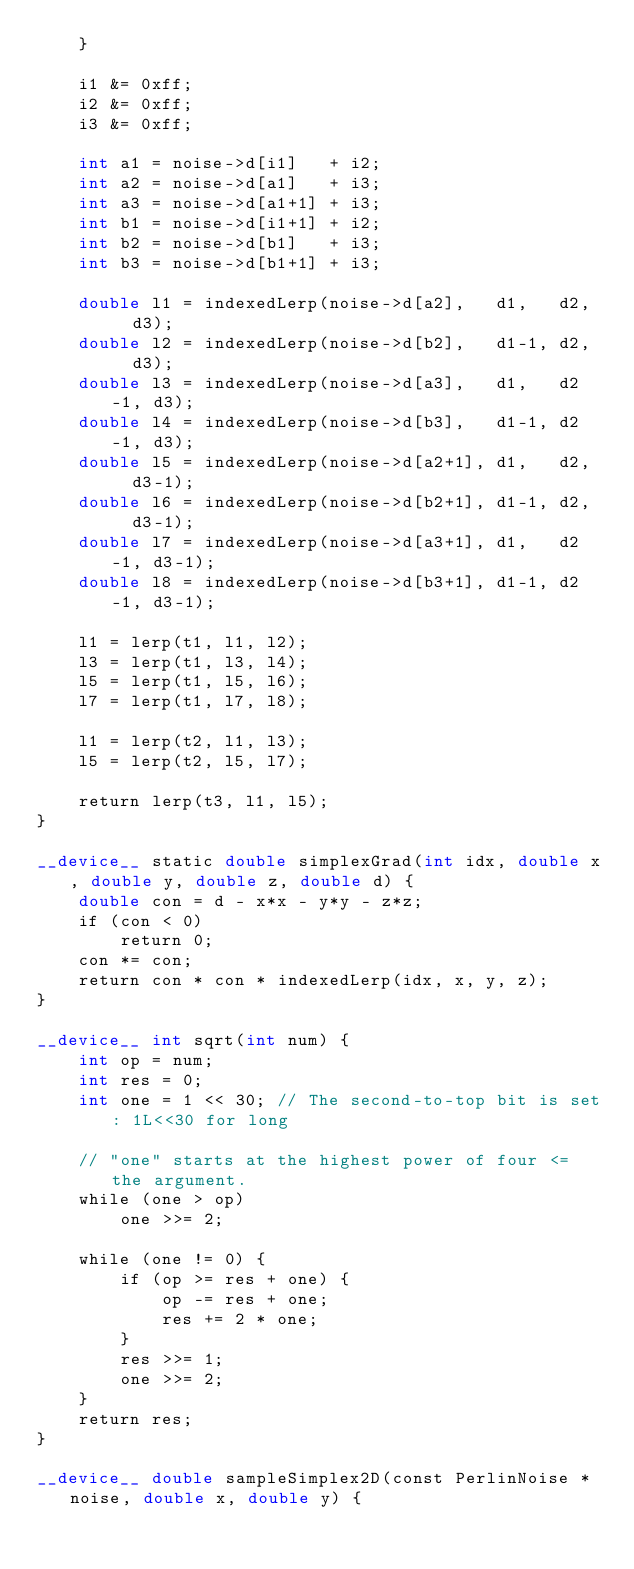<code> <loc_0><loc_0><loc_500><loc_500><_Cuda_>    }

    i1 &= 0xff;
    i2 &= 0xff;
    i3 &= 0xff;

    int a1 = noise->d[i1]   + i2;
    int a2 = noise->d[a1]   + i3;
    int a3 = noise->d[a1+1] + i3;
    int b1 = noise->d[i1+1] + i2;
    int b2 = noise->d[b1]   + i3;
    int b3 = noise->d[b1+1] + i3;

    double l1 = indexedLerp(noise->d[a2],   d1,   d2,   d3);
    double l2 = indexedLerp(noise->d[b2],   d1-1, d2,   d3);
    double l3 = indexedLerp(noise->d[a3],   d1,   d2-1, d3);
    double l4 = indexedLerp(noise->d[b3],   d1-1, d2-1, d3);
    double l5 = indexedLerp(noise->d[a2+1], d1,   d2,   d3-1);
    double l6 = indexedLerp(noise->d[b2+1], d1-1, d2,   d3-1);
    double l7 = indexedLerp(noise->d[a3+1], d1,   d2-1, d3-1);
    double l8 = indexedLerp(noise->d[b3+1], d1-1, d2-1, d3-1);

    l1 = lerp(t1, l1, l2);
    l3 = lerp(t1, l3, l4);
    l5 = lerp(t1, l5, l6);
    l7 = lerp(t1, l7, l8);

    l1 = lerp(t2, l1, l3);
    l5 = lerp(t2, l5, l7);

    return lerp(t3, l1, l5);
}

__device__ static double simplexGrad(int idx, double x, double y, double z, double d) {
    double con = d - x*x - y*y - z*z;
    if (con < 0)
        return 0;
    con *= con;
    return con * con * indexedLerp(idx, x, y, z);
}

__device__ int sqrt(int num) {
    int op = num;
    int res = 0;
    int one = 1 << 30; // The second-to-top bit is set: 1L<<30 for long

    // "one" starts at the highest power of four <= the argument.
    while (one > op)
        one >>= 2;

    while (one != 0) {
        if (op >= res + one) {
            op -= res + one;
            res += 2 * one;
        }
        res >>= 1;
        one >>= 2;
    }
    return res;
}

__device__ double sampleSimplex2D(const PerlinNoise *noise, double x, double y) {</code> 